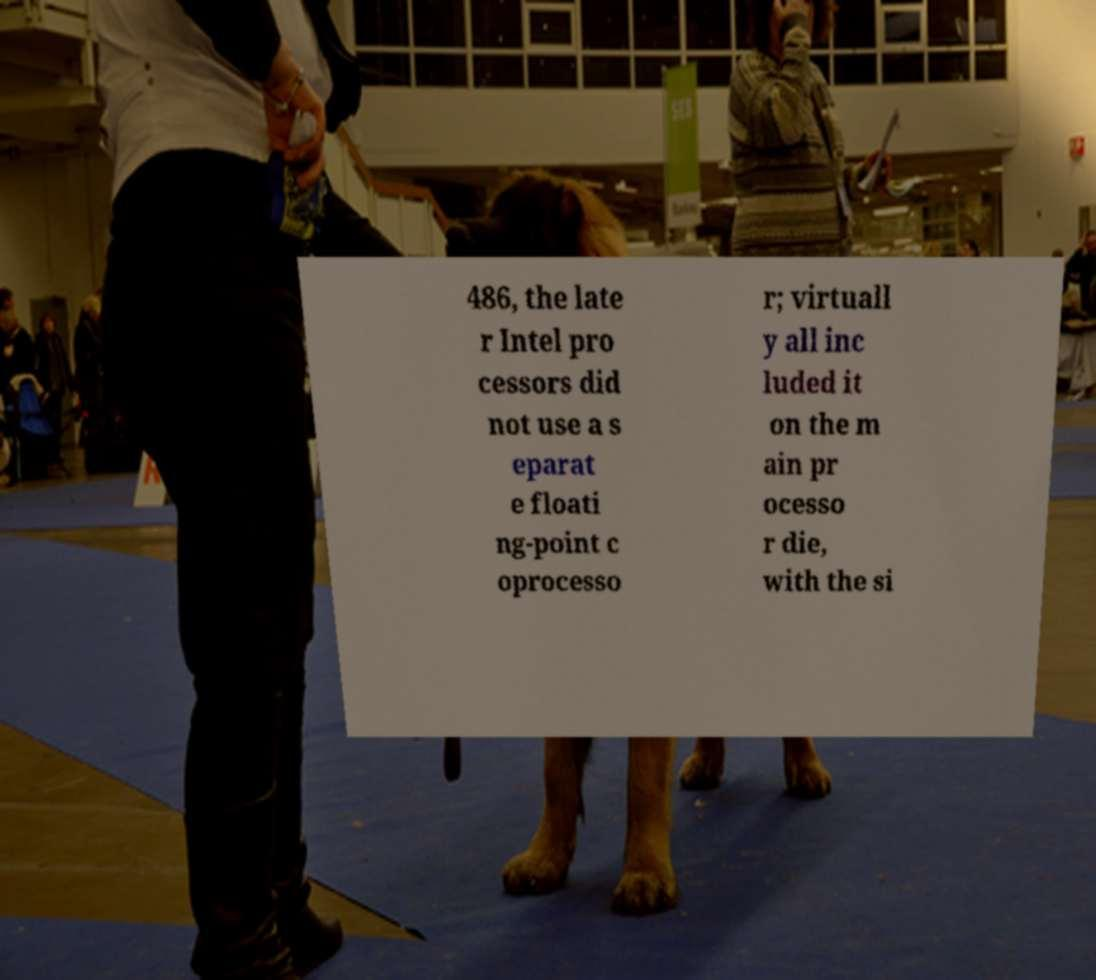Could you extract and type out the text from this image? 486, the late r Intel pro cessors did not use a s eparat e floati ng-point c oprocesso r; virtuall y all inc luded it on the m ain pr ocesso r die, with the si 